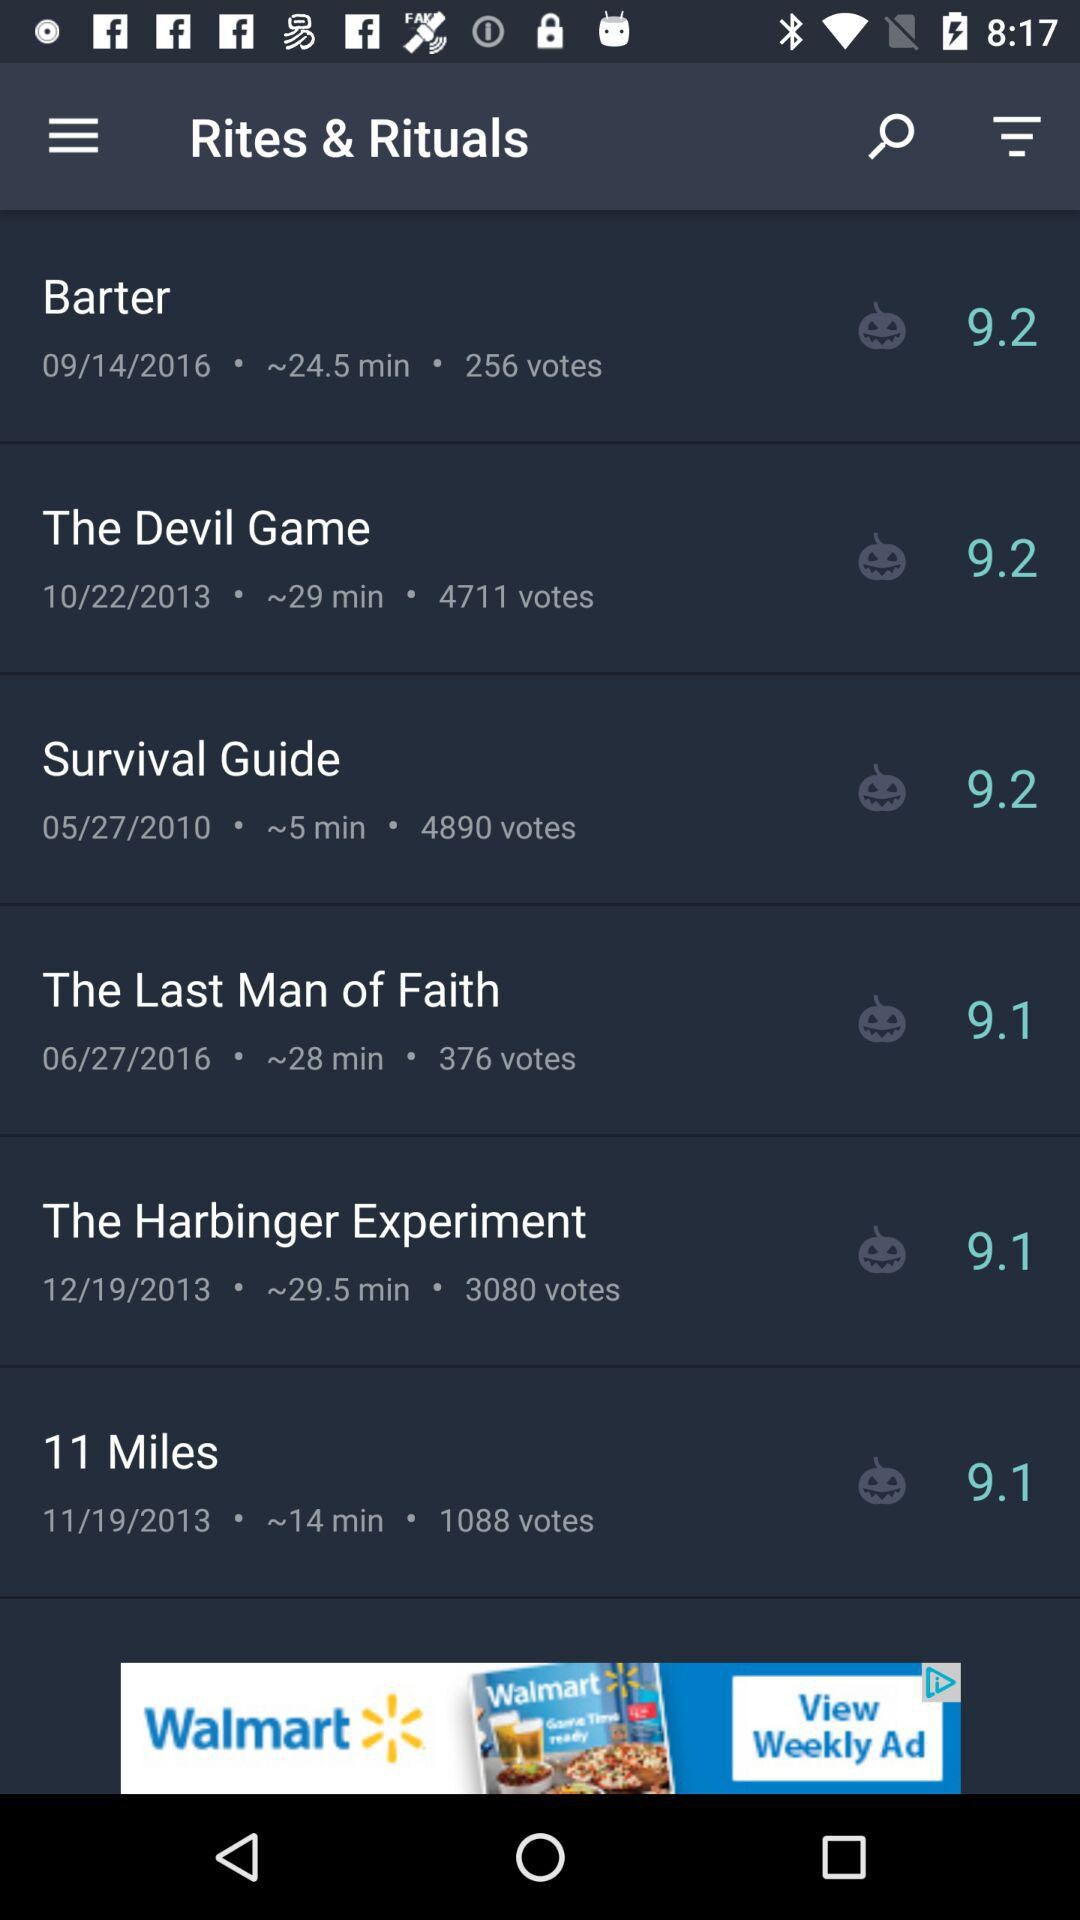What is the date of barter? The date is September 14, 2016. 